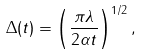Convert formula to latex. <formula><loc_0><loc_0><loc_500><loc_500>\Delta ( t ) = \left ( \frac { \pi \lambda } { 2 \alpha t } \right ) ^ { 1 / 2 } ,</formula> 